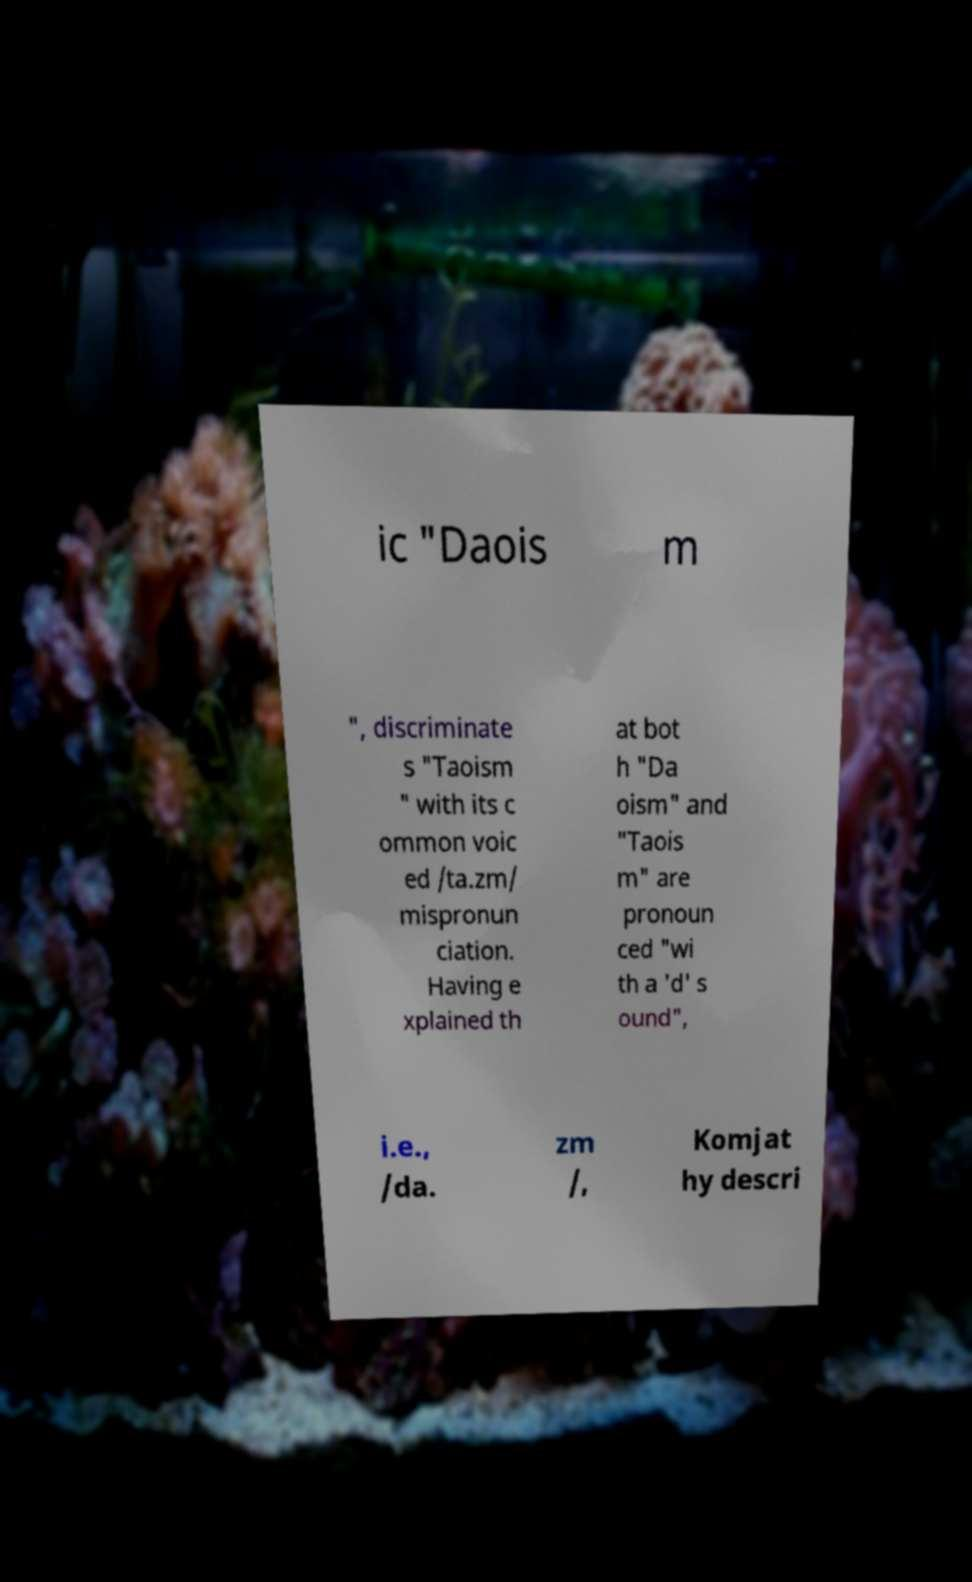Please identify and transcribe the text found in this image. ic "Daois m ", discriminate s "Taoism " with its c ommon voic ed /ta.zm/ mispronun ciation. Having e xplained th at bot h "Da oism" and "Taois m" are pronoun ced "wi th a 'd' s ound", i.e., /da. zm /, Komjat hy descri 